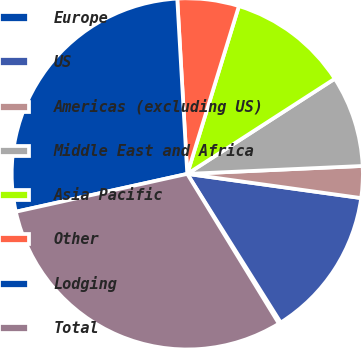Convert chart to OTSL. <chart><loc_0><loc_0><loc_500><loc_500><pie_chart><fcel>Europe<fcel>US<fcel>Americas (excluding US)<fcel>Middle East and Africa<fcel>Asia Pacific<fcel>Other<fcel>Lodging<fcel>Total<nl><fcel>0.19%<fcel>13.87%<fcel>2.92%<fcel>8.4%<fcel>11.13%<fcel>5.66%<fcel>27.55%<fcel>30.28%<nl></chart> 